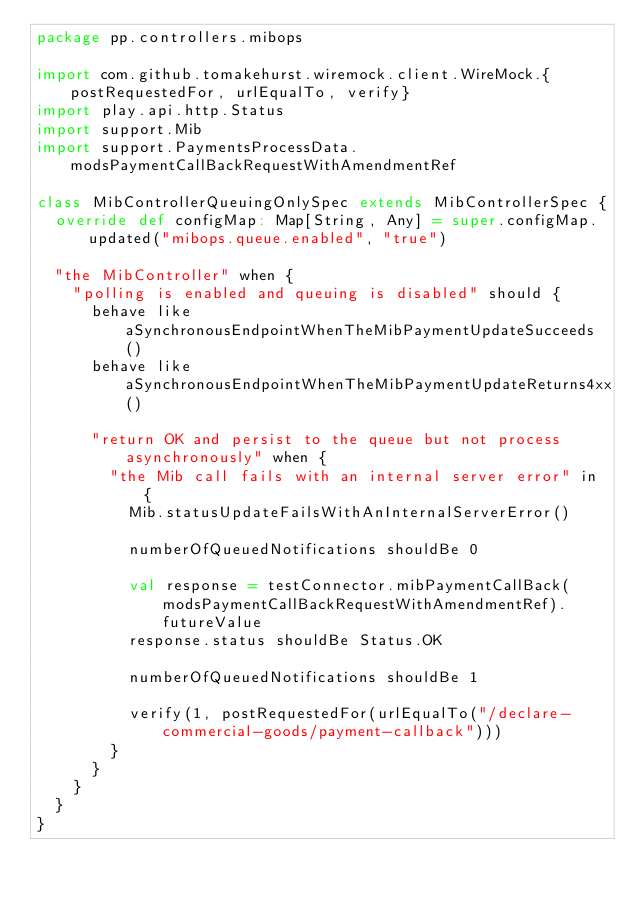<code> <loc_0><loc_0><loc_500><loc_500><_Scala_>package pp.controllers.mibops

import com.github.tomakehurst.wiremock.client.WireMock.{postRequestedFor, urlEqualTo, verify}
import play.api.http.Status
import support.Mib
import support.PaymentsProcessData.modsPaymentCallBackRequestWithAmendmentRef

class MibControllerQueuingOnlySpec extends MibControllerSpec {
  override def configMap: Map[String, Any] = super.configMap.updated("mibops.queue.enabled", "true")

  "the MibController" when {
    "polling is enabled and queuing is disabled" should {
      behave like aSynchronousEndpointWhenTheMibPaymentUpdateSucceeds()
      behave like aSynchronousEndpointWhenTheMibPaymentUpdateReturns4xx()

      "return OK and persist to the queue but not process asynchronously" when {
        "the Mib call fails with an internal server error" in {
          Mib.statusUpdateFailsWithAnInternalServerError()

          numberOfQueuedNotifications shouldBe 0

          val response = testConnector.mibPaymentCallBack(modsPaymentCallBackRequestWithAmendmentRef).futureValue
          response.status shouldBe Status.OK

          numberOfQueuedNotifications shouldBe 1

          verify(1, postRequestedFor(urlEqualTo("/declare-commercial-goods/payment-callback")))
        }
      }
    }
  }
}
</code> 